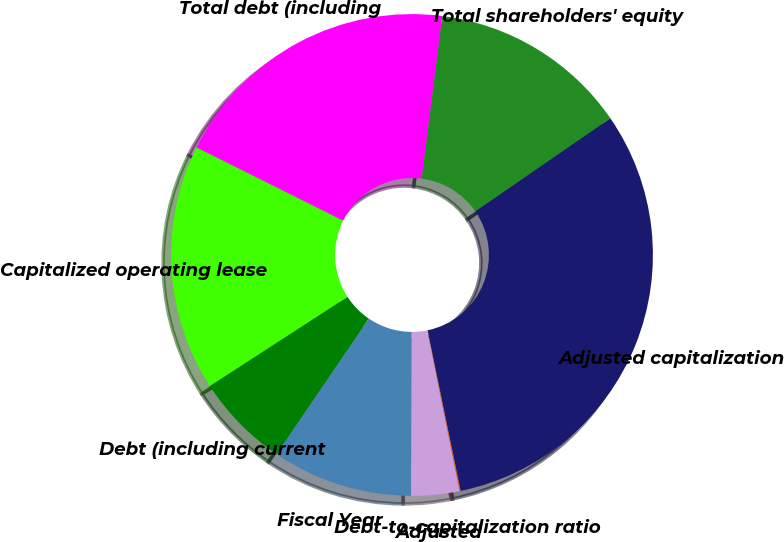Convert chart. <chart><loc_0><loc_0><loc_500><loc_500><pie_chart><fcel>Fiscal Year<fcel>Debt (including current<fcel>Capitalized operating lease<fcel>Total debt (including<fcel>Total shareholders' equity<fcel>Adjusted capitalization<fcel>Debt-to-capitalization ratio<fcel>Adjusted<nl><fcel>9.46%<fcel>6.34%<fcel>16.52%<fcel>19.64%<fcel>13.39%<fcel>31.37%<fcel>0.08%<fcel>3.21%<nl></chart> 